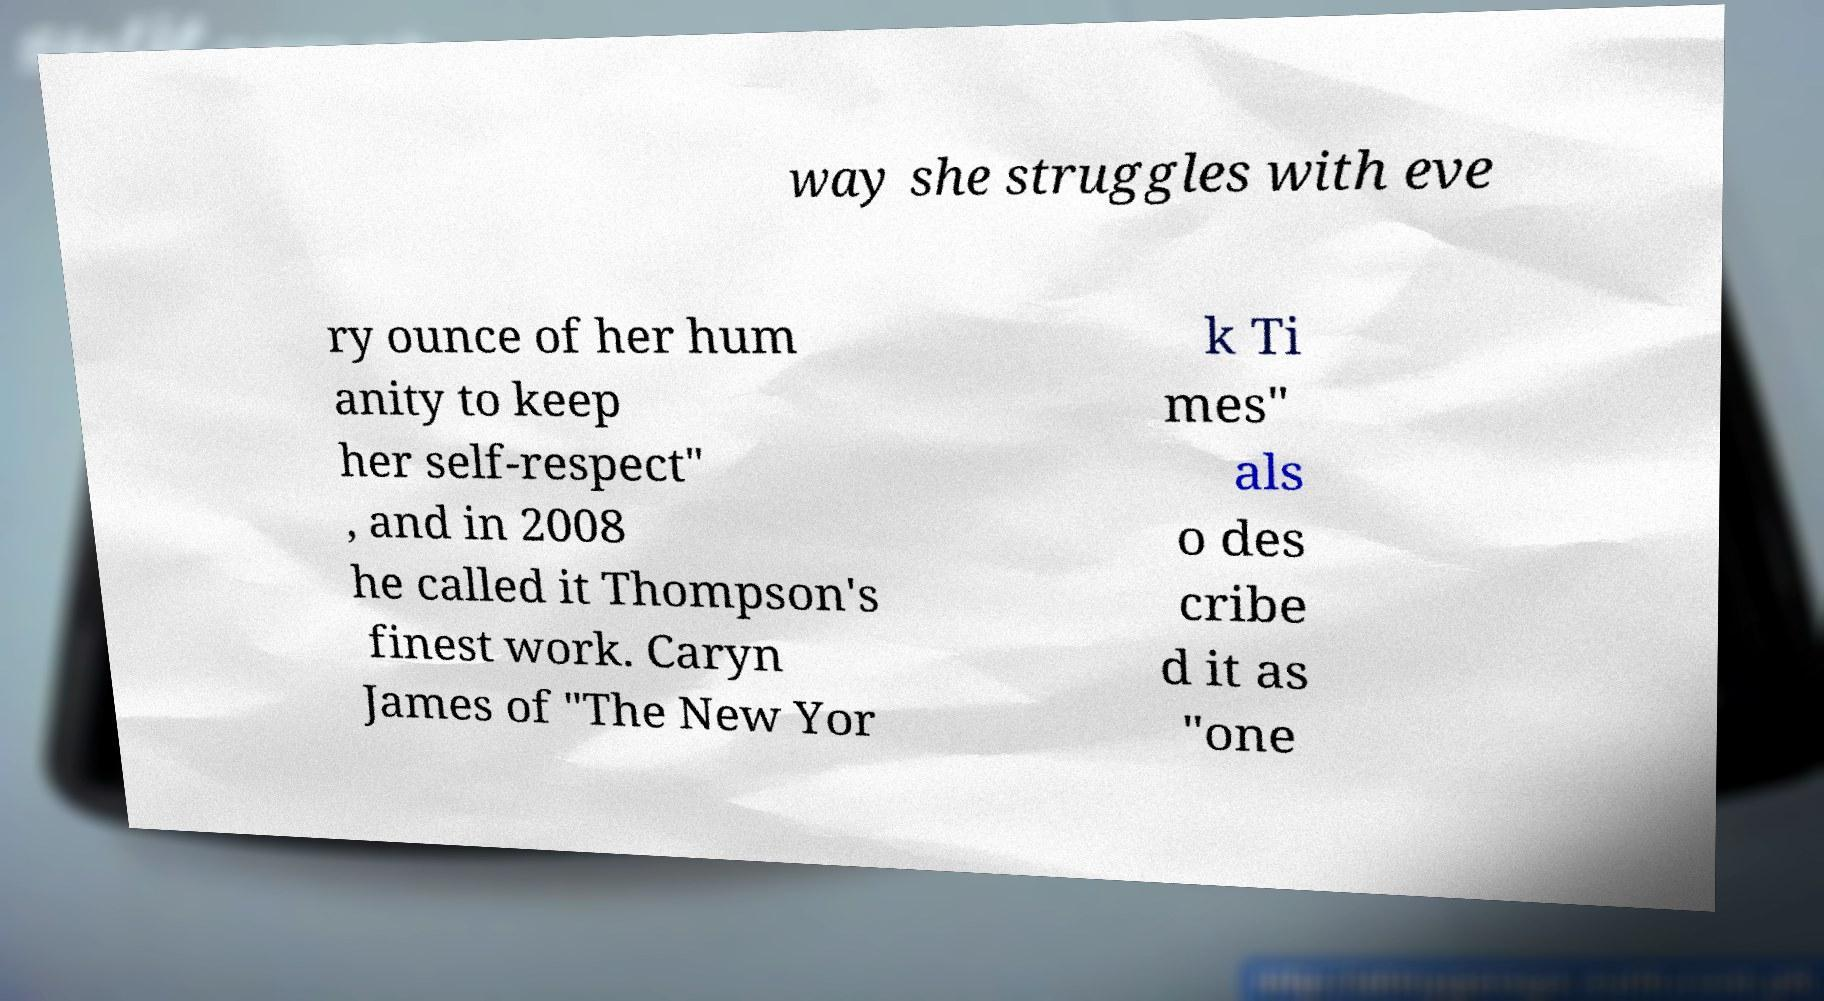I need the written content from this picture converted into text. Can you do that? way she struggles with eve ry ounce of her hum anity to keep her self-respect" , and in 2008 he called it Thompson's finest work. Caryn James of "The New Yor k Ti mes" als o des cribe d it as "one 